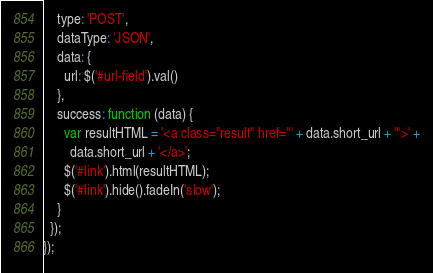Convert code to text. <code><loc_0><loc_0><loc_500><loc_500><_JavaScript_>    type: 'POST',
    dataType: 'JSON',
    data: {
      url: $('#url-field').val()
    },
    success: function (data) {
      var resultHTML = '<a class="result" href="' + data.short_url + '">' +
        data.short_url + '</a>';
      $('#link').html(resultHTML);
      $('#link').hide().fadeIn('slow');
    }
  });
});
</code> 